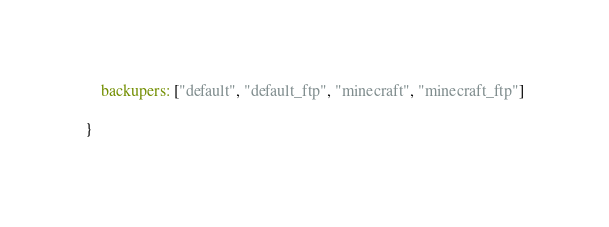Convert code to text. <code><loc_0><loc_0><loc_500><loc_500><_JavaScript_>    backupers: ["default", "default_ftp", "minecraft", "minecraft_ftp"]

}</code> 